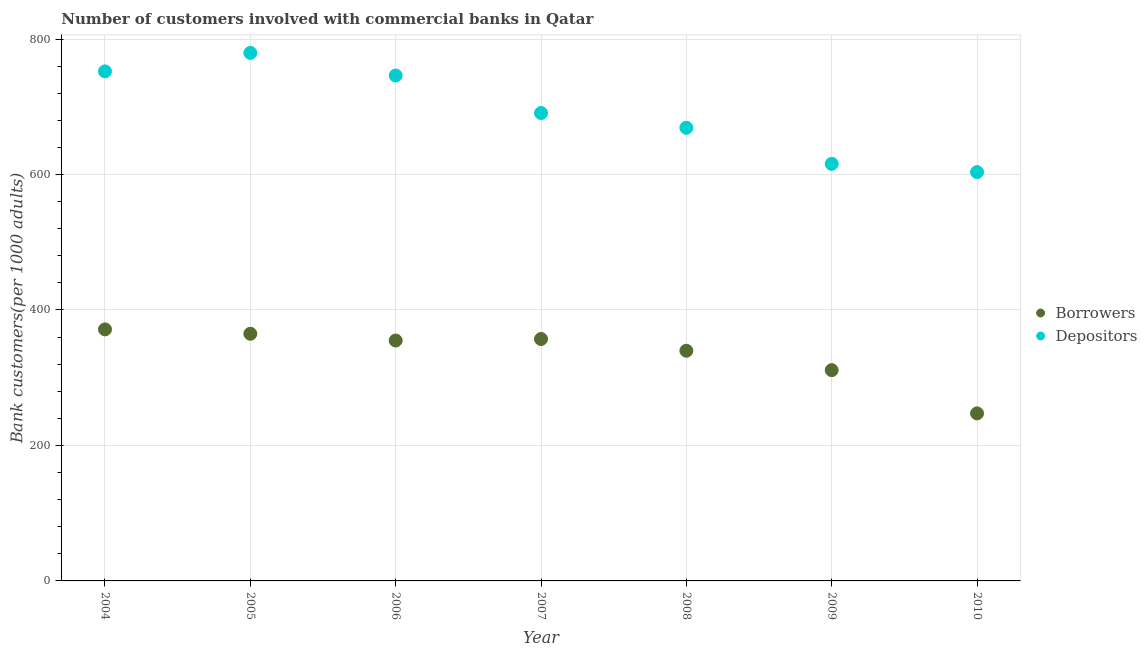What is the number of borrowers in 2010?
Your answer should be compact. 247.33. Across all years, what is the maximum number of depositors?
Provide a succinct answer. 779.56. Across all years, what is the minimum number of borrowers?
Ensure brevity in your answer.  247.33. What is the total number of depositors in the graph?
Make the answer very short. 4857.09. What is the difference between the number of borrowers in 2007 and that in 2008?
Provide a short and direct response. 17.35. What is the difference between the number of depositors in 2010 and the number of borrowers in 2008?
Keep it short and to the point. 263.74. What is the average number of depositors per year?
Provide a short and direct response. 693.87. In the year 2004, what is the difference between the number of depositors and number of borrowers?
Ensure brevity in your answer.  380.94. In how many years, is the number of borrowers greater than 440?
Ensure brevity in your answer.  0. What is the ratio of the number of depositors in 2004 to that in 2006?
Provide a succinct answer. 1.01. Is the number of depositors in 2005 less than that in 2009?
Offer a very short reply. No. What is the difference between the highest and the second highest number of borrowers?
Offer a terse response. 6.45. What is the difference between the highest and the lowest number of borrowers?
Your answer should be very brief. 124.01. In how many years, is the number of borrowers greater than the average number of borrowers taken over all years?
Offer a very short reply. 5. Does the number of borrowers monotonically increase over the years?
Provide a short and direct response. No. Is the number of borrowers strictly less than the number of depositors over the years?
Provide a short and direct response. Yes. How many dotlines are there?
Provide a short and direct response. 2. How many years are there in the graph?
Your answer should be compact. 7. What is the difference between two consecutive major ticks on the Y-axis?
Your response must be concise. 200. Are the values on the major ticks of Y-axis written in scientific E-notation?
Your answer should be compact. No. Does the graph contain any zero values?
Your response must be concise. No. Does the graph contain grids?
Your answer should be very brief. Yes. Where does the legend appear in the graph?
Ensure brevity in your answer.  Center right. What is the title of the graph?
Keep it short and to the point. Number of customers involved with commercial banks in Qatar. Does "From production" appear as one of the legend labels in the graph?
Provide a succinct answer. No. What is the label or title of the Y-axis?
Offer a very short reply. Bank customers(per 1000 adults). What is the Bank customers(per 1000 adults) of Borrowers in 2004?
Provide a short and direct response. 371.34. What is the Bank customers(per 1000 adults) in Depositors in 2004?
Offer a very short reply. 752.28. What is the Bank customers(per 1000 adults) of Borrowers in 2005?
Keep it short and to the point. 364.89. What is the Bank customers(per 1000 adults) in Depositors in 2005?
Offer a terse response. 779.56. What is the Bank customers(per 1000 adults) of Borrowers in 2006?
Your answer should be very brief. 354.93. What is the Bank customers(per 1000 adults) in Depositors in 2006?
Make the answer very short. 746.16. What is the Bank customers(per 1000 adults) of Borrowers in 2007?
Provide a succinct answer. 357.18. What is the Bank customers(per 1000 adults) of Depositors in 2007?
Offer a very short reply. 690.79. What is the Bank customers(per 1000 adults) in Borrowers in 2008?
Provide a succinct answer. 339.83. What is the Bank customers(per 1000 adults) in Depositors in 2008?
Provide a succinct answer. 668.99. What is the Bank customers(per 1000 adults) in Borrowers in 2009?
Keep it short and to the point. 311.18. What is the Bank customers(per 1000 adults) of Depositors in 2009?
Provide a succinct answer. 615.73. What is the Bank customers(per 1000 adults) in Borrowers in 2010?
Your response must be concise. 247.33. What is the Bank customers(per 1000 adults) of Depositors in 2010?
Your response must be concise. 603.57. Across all years, what is the maximum Bank customers(per 1000 adults) in Borrowers?
Make the answer very short. 371.34. Across all years, what is the maximum Bank customers(per 1000 adults) in Depositors?
Your answer should be very brief. 779.56. Across all years, what is the minimum Bank customers(per 1000 adults) of Borrowers?
Provide a short and direct response. 247.33. Across all years, what is the minimum Bank customers(per 1000 adults) in Depositors?
Provide a succinct answer. 603.57. What is the total Bank customers(per 1000 adults) of Borrowers in the graph?
Ensure brevity in your answer.  2346.67. What is the total Bank customers(per 1000 adults) in Depositors in the graph?
Provide a short and direct response. 4857.09. What is the difference between the Bank customers(per 1000 adults) of Borrowers in 2004 and that in 2005?
Give a very brief answer. 6.45. What is the difference between the Bank customers(per 1000 adults) of Depositors in 2004 and that in 2005?
Offer a terse response. -27.27. What is the difference between the Bank customers(per 1000 adults) of Borrowers in 2004 and that in 2006?
Make the answer very short. 16.41. What is the difference between the Bank customers(per 1000 adults) of Depositors in 2004 and that in 2006?
Provide a short and direct response. 6.12. What is the difference between the Bank customers(per 1000 adults) of Borrowers in 2004 and that in 2007?
Make the answer very short. 14.16. What is the difference between the Bank customers(per 1000 adults) in Depositors in 2004 and that in 2007?
Give a very brief answer. 61.49. What is the difference between the Bank customers(per 1000 adults) of Borrowers in 2004 and that in 2008?
Give a very brief answer. 31.51. What is the difference between the Bank customers(per 1000 adults) of Depositors in 2004 and that in 2008?
Keep it short and to the point. 83.29. What is the difference between the Bank customers(per 1000 adults) of Borrowers in 2004 and that in 2009?
Keep it short and to the point. 60.16. What is the difference between the Bank customers(per 1000 adults) in Depositors in 2004 and that in 2009?
Ensure brevity in your answer.  136.56. What is the difference between the Bank customers(per 1000 adults) in Borrowers in 2004 and that in 2010?
Your response must be concise. 124.01. What is the difference between the Bank customers(per 1000 adults) in Depositors in 2004 and that in 2010?
Ensure brevity in your answer.  148.71. What is the difference between the Bank customers(per 1000 adults) of Borrowers in 2005 and that in 2006?
Ensure brevity in your answer.  9.96. What is the difference between the Bank customers(per 1000 adults) in Depositors in 2005 and that in 2006?
Your response must be concise. 33.4. What is the difference between the Bank customers(per 1000 adults) of Borrowers in 2005 and that in 2007?
Offer a very short reply. 7.71. What is the difference between the Bank customers(per 1000 adults) of Depositors in 2005 and that in 2007?
Your answer should be compact. 88.76. What is the difference between the Bank customers(per 1000 adults) of Borrowers in 2005 and that in 2008?
Give a very brief answer. 25.06. What is the difference between the Bank customers(per 1000 adults) in Depositors in 2005 and that in 2008?
Offer a terse response. 110.57. What is the difference between the Bank customers(per 1000 adults) of Borrowers in 2005 and that in 2009?
Give a very brief answer. 53.71. What is the difference between the Bank customers(per 1000 adults) of Depositors in 2005 and that in 2009?
Make the answer very short. 163.83. What is the difference between the Bank customers(per 1000 adults) of Borrowers in 2005 and that in 2010?
Ensure brevity in your answer.  117.56. What is the difference between the Bank customers(per 1000 adults) in Depositors in 2005 and that in 2010?
Offer a very short reply. 175.98. What is the difference between the Bank customers(per 1000 adults) in Borrowers in 2006 and that in 2007?
Offer a terse response. -2.25. What is the difference between the Bank customers(per 1000 adults) of Depositors in 2006 and that in 2007?
Provide a succinct answer. 55.37. What is the difference between the Bank customers(per 1000 adults) of Borrowers in 2006 and that in 2008?
Make the answer very short. 15.1. What is the difference between the Bank customers(per 1000 adults) of Depositors in 2006 and that in 2008?
Provide a short and direct response. 77.17. What is the difference between the Bank customers(per 1000 adults) in Borrowers in 2006 and that in 2009?
Provide a short and direct response. 43.74. What is the difference between the Bank customers(per 1000 adults) of Depositors in 2006 and that in 2009?
Ensure brevity in your answer.  130.43. What is the difference between the Bank customers(per 1000 adults) of Borrowers in 2006 and that in 2010?
Your response must be concise. 107.6. What is the difference between the Bank customers(per 1000 adults) in Depositors in 2006 and that in 2010?
Your answer should be very brief. 142.59. What is the difference between the Bank customers(per 1000 adults) in Borrowers in 2007 and that in 2008?
Provide a succinct answer. 17.35. What is the difference between the Bank customers(per 1000 adults) of Depositors in 2007 and that in 2008?
Offer a very short reply. 21.8. What is the difference between the Bank customers(per 1000 adults) in Borrowers in 2007 and that in 2009?
Give a very brief answer. 46. What is the difference between the Bank customers(per 1000 adults) of Depositors in 2007 and that in 2009?
Provide a succinct answer. 75.07. What is the difference between the Bank customers(per 1000 adults) in Borrowers in 2007 and that in 2010?
Make the answer very short. 109.85. What is the difference between the Bank customers(per 1000 adults) of Depositors in 2007 and that in 2010?
Keep it short and to the point. 87.22. What is the difference between the Bank customers(per 1000 adults) in Borrowers in 2008 and that in 2009?
Your response must be concise. 28.65. What is the difference between the Bank customers(per 1000 adults) in Depositors in 2008 and that in 2009?
Give a very brief answer. 53.27. What is the difference between the Bank customers(per 1000 adults) of Borrowers in 2008 and that in 2010?
Give a very brief answer. 92.5. What is the difference between the Bank customers(per 1000 adults) in Depositors in 2008 and that in 2010?
Make the answer very short. 65.42. What is the difference between the Bank customers(per 1000 adults) in Borrowers in 2009 and that in 2010?
Make the answer very short. 63.85. What is the difference between the Bank customers(per 1000 adults) in Depositors in 2009 and that in 2010?
Offer a terse response. 12.15. What is the difference between the Bank customers(per 1000 adults) of Borrowers in 2004 and the Bank customers(per 1000 adults) of Depositors in 2005?
Your answer should be compact. -408.22. What is the difference between the Bank customers(per 1000 adults) in Borrowers in 2004 and the Bank customers(per 1000 adults) in Depositors in 2006?
Your answer should be compact. -374.82. What is the difference between the Bank customers(per 1000 adults) in Borrowers in 2004 and the Bank customers(per 1000 adults) in Depositors in 2007?
Ensure brevity in your answer.  -319.46. What is the difference between the Bank customers(per 1000 adults) of Borrowers in 2004 and the Bank customers(per 1000 adults) of Depositors in 2008?
Your answer should be very brief. -297.65. What is the difference between the Bank customers(per 1000 adults) in Borrowers in 2004 and the Bank customers(per 1000 adults) in Depositors in 2009?
Offer a very short reply. -244.39. What is the difference between the Bank customers(per 1000 adults) of Borrowers in 2004 and the Bank customers(per 1000 adults) of Depositors in 2010?
Offer a very short reply. -232.23. What is the difference between the Bank customers(per 1000 adults) of Borrowers in 2005 and the Bank customers(per 1000 adults) of Depositors in 2006?
Give a very brief answer. -381.27. What is the difference between the Bank customers(per 1000 adults) of Borrowers in 2005 and the Bank customers(per 1000 adults) of Depositors in 2007?
Offer a very short reply. -325.91. What is the difference between the Bank customers(per 1000 adults) of Borrowers in 2005 and the Bank customers(per 1000 adults) of Depositors in 2008?
Your answer should be compact. -304.1. What is the difference between the Bank customers(per 1000 adults) of Borrowers in 2005 and the Bank customers(per 1000 adults) of Depositors in 2009?
Provide a succinct answer. -250.84. What is the difference between the Bank customers(per 1000 adults) in Borrowers in 2005 and the Bank customers(per 1000 adults) in Depositors in 2010?
Make the answer very short. -238.68. What is the difference between the Bank customers(per 1000 adults) of Borrowers in 2006 and the Bank customers(per 1000 adults) of Depositors in 2007?
Provide a succinct answer. -335.87. What is the difference between the Bank customers(per 1000 adults) in Borrowers in 2006 and the Bank customers(per 1000 adults) in Depositors in 2008?
Your response must be concise. -314.06. What is the difference between the Bank customers(per 1000 adults) of Borrowers in 2006 and the Bank customers(per 1000 adults) of Depositors in 2009?
Offer a very short reply. -260.8. What is the difference between the Bank customers(per 1000 adults) in Borrowers in 2006 and the Bank customers(per 1000 adults) in Depositors in 2010?
Ensure brevity in your answer.  -248.65. What is the difference between the Bank customers(per 1000 adults) of Borrowers in 2007 and the Bank customers(per 1000 adults) of Depositors in 2008?
Provide a short and direct response. -311.81. What is the difference between the Bank customers(per 1000 adults) of Borrowers in 2007 and the Bank customers(per 1000 adults) of Depositors in 2009?
Your answer should be compact. -258.55. What is the difference between the Bank customers(per 1000 adults) of Borrowers in 2007 and the Bank customers(per 1000 adults) of Depositors in 2010?
Provide a succinct answer. -246.39. What is the difference between the Bank customers(per 1000 adults) in Borrowers in 2008 and the Bank customers(per 1000 adults) in Depositors in 2009?
Provide a short and direct response. -275.9. What is the difference between the Bank customers(per 1000 adults) in Borrowers in 2008 and the Bank customers(per 1000 adults) in Depositors in 2010?
Keep it short and to the point. -263.74. What is the difference between the Bank customers(per 1000 adults) in Borrowers in 2009 and the Bank customers(per 1000 adults) in Depositors in 2010?
Keep it short and to the point. -292.39. What is the average Bank customers(per 1000 adults) of Borrowers per year?
Offer a terse response. 335.24. What is the average Bank customers(per 1000 adults) of Depositors per year?
Offer a terse response. 693.87. In the year 2004, what is the difference between the Bank customers(per 1000 adults) of Borrowers and Bank customers(per 1000 adults) of Depositors?
Provide a succinct answer. -380.94. In the year 2005, what is the difference between the Bank customers(per 1000 adults) of Borrowers and Bank customers(per 1000 adults) of Depositors?
Give a very brief answer. -414.67. In the year 2006, what is the difference between the Bank customers(per 1000 adults) in Borrowers and Bank customers(per 1000 adults) in Depositors?
Your answer should be very brief. -391.23. In the year 2007, what is the difference between the Bank customers(per 1000 adults) in Borrowers and Bank customers(per 1000 adults) in Depositors?
Ensure brevity in your answer.  -333.62. In the year 2008, what is the difference between the Bank customers(per 1000 adults) in Borrowers and Bank customers(per 1000 adults) in Depositors?
Give a very brief answer. -329.16. In the year 2009, what is the difference between the Bank customers(per 1000 adults) of Borrowers and Bank customers(per 1000 adults) of Depositors?
Provide a succinct answer. -304.54. In the year 2010, what is the difference between the Bank customers(per 1000 adults) in Borrowers and Bank customers(per 1000 adults) in Depositors?
Make the answer very short. -356.24. What is the ratio of the Bank customers(per 1000 adults) of Borrowers in 2004 to that in 2005?
Give a very brief answer. 1.02. What is the ratio of the Bank customers(per 1000 adults) in Depositors in 2004 to that in 2005?
Make the answer very short. 0.96. What is the ratio of the Bank customers(per 1000 adults) in Borrowers in 2004 to that in 2006?
Your response must be concise. 1.05. What is the ratio of the Bank customers(per 1000 adults) of Depositors in 2004 to that in 2006?
Ensure brevity in your answer.  1.01. What is the ratio of the Bank customers(per 1000 adults) of Borrowers in 2004 to that in 2007?
Your response must be concise. 1.04. What is the ratio of the Bank customers(per 1000 adults) in Depositors in 2004 to that in 2007?
Make the answer very short. 1.09. What is the ratio of the Bank customers(per 1000 adults) of Borrowers in 2004 to that in 2008?
Your answer should be very brief. 1.09. What is the ratio of the Bank customers(per 1000 adults) in Depositors in 2004 to that in 2008?
Offer a very short reply. 1.12. What is the ratio of the Bank customers(per 1000 adults) in Borrowers in 2004 to that in 2009?
Give a very brief answer. 1.19. What is the ratio of the Bank customers(per 1000 adults) in Depositors in 2004 to that in 2009?
Provide a succinct answer. 1.22. What is the ratio of the Bank customers(per 1000 adults) in Borrowers in 2004 to that in 2010?
Ensure brevity in your answer.  1.5. What is the ratio of the Bank customers(per 1000 adults) of Depositors in 2004 to that in 2010?
Provide a succinct answer. 1.25. What is the ratio of the Bank customers(per 1000 adults) of Borrowers in 2005 to that in 2006?
Provide a short and direct response. 1.03. What is the ratio of the Bank customers(per 1000 adults) in Depositors in 2005 to that in 2006?
Offer a very short reply. 1.04. What is the ratio of the Bank customers(per 1000 adults) in Borrowers in 2005 to that in 2007?
Ensure brevity in your answer.  1.02. What is the ratio of the Bank customers(per 1000 adults) of Depositors in 2005 to that in 2007?
Provide a succinct answer. 1.13. What is the ratio of the Bank customers(per 1000 adults) in Borrowers in 2005 to that in 2008?
Offer a terse response. 1.07. What is the ratio of the Bank customers(per 1000 adults) of Depositors in 2005 to that in 2008?
Your answer should be compact. 1.17. What is the ratio of the Bank customers(per 1000 adults) in Borrowers in 2005 to that in 2009?
Offer a very short reply. 1.17. What is the ratio of the Bank customers(per 1000 adults) of Depositors in 2005 to that in 2009?
Keep it short and to the point. 1.27. What is the ratio of the Bank customers(per 1000 adults) of Borrowers in 2005 to that in 2010?
Provide a short and direct response. 1.48. What is the ratio of the Bank customers(per 1000 adults) of Depositors in 2005 to that in 2010?
Your response must be concise. 1.29. What is the ratio of the Bank customers(per 1000 adults) in Depositors in 2006 to that in 2007?
Give a very brief answer. 1.08. What is the ratio of the Bank customers(per 1000 adults) in Borrowers in 2006 to that in 2008?
Give a very brief answer. 1.04. What is the ratio of the Bank customers(per 1000 adults) of Depositors in 2006 to that in 2008?
Provide a succinct answer. 1.12. What is the ratio of the Bank customers(per 1000 adults) of Borrowers in 2006 to that in 2009?
Provide a short and direct response. 1.14. What is the ratio of the Bank customers(per 1000 adults) in Depositors in 2006 to that in 2009?
Provide a short and direct response. 1.21. What is the ratio of the Bank customers(per 1000 adults) of Borrowers in 2006 to that in 2010?
Provide a short and direct response. 1.44. What is the ratio of the Bank customers(per 1000 adults) of Depositors in 2006 to that in 2010?
Your answer should be compact. 1.24. What is the ratio of the Bank customers(per 1000 adults) in Borrowers in 2007 to that in 2008?
Make the answer very short. 1.05. What is the ratio of the Bank customers(per 1000 adults) in Depositors in 2007 to that in 2008?
Give a very brief answer. 1.03. What is the ratio of the Bank customers(per 1000 adults) of Borrowers in 2007 to that in 2009?
Give a very brief answer. 1.15. What is the ratio of the Bank customers(per 1000 adults) in Depositors in 2007 to that in 2009?
Your answer should be compact. 1.12. What is the ratio of the Bank customers(per 1000 adults) in Borrowers in 2007 to that in 2010?
Keep it short and to the point. 1.44. What is the ratio of the Bank customers(per 1000 adults) in Depositors in 2007 to that in 2010?
Ensure brevity in your answer.  1.14. What is the ratio of the Bank customers(per 1000 adults) of Borrowers in 2008 to that in 2009?
Your answer should be very brief. 1.09. What is the ratio of the Bank customers(per 1000 adults) in Depositors in 2008 to that in 2009?
Offer a terse response. 1.09. What is the ratio of the Bank customers(per 1000 adults) of Borrowers in 2008 to that in 2010?
Keep it short and to the point. 1.37. What is the ratio of the Bank customers(per 1000 adults) in Depositors in 2008 to that in 2010?
Offer a terse response. 1.11. What is the ratio of the Bank customers(per 1000 adults) in Borrowers in 2009 to that in 2010?
Provide a short and direct response. 1.26. What is the ratio of the Bank customers(per 1000 adults) in Depositors in 2009 to that in 2010?
Your answer should be compact. 1.02. What is the difference between the highest and the second highest Bank customers(per 1000 adults) in Borrowers?
Your answer should be compact. 6.45. What is the difference between the highest and the second highest Bank customers(per 1000 adults) of Depositors?
Offer a very short reply. 27.27. What is the difference between the highest and the lowest Bank customers(per 1000 adults) in Borrowers?
Make the answer very short. 124.01. What is the difference between the highest and the lowest Bank customers(per 1000 adults) in Depositors?
Ensure brevity in your answer.  175.98. 